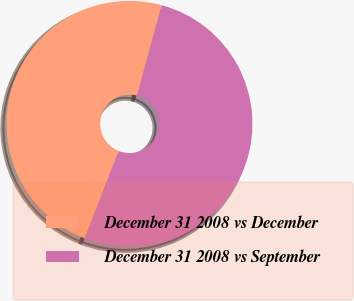Convert chart to OTSL. <chart><loc_0><loc_0><loc_500><loc_500><pie_chart><fcel>December 31 2008 vs December<fcel>December 31 2008 vs September<nl><fcel>48.33%<fcel>51.67%<nl></chart> 